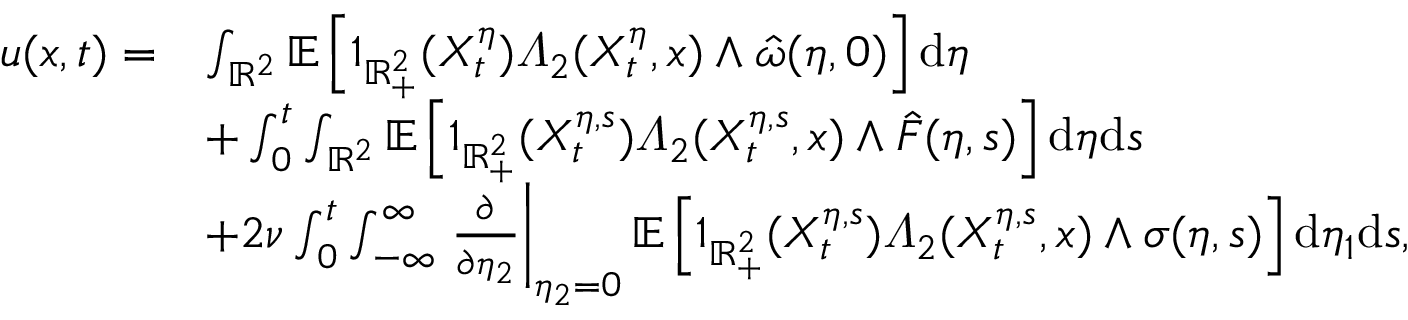Convert formula to latex. <formula><loc_0><loc_0><loc_500><loc_500>\begin{array} { r l } { u ( x , t ) = } & { \int _ { \mathbb { R } ^ { 2 } } \mathbb { E } \left [ 1 _ { \mathbb { R } _ { + } ^ { 2 } } ( X _ { t } ^ { \eta } ) \varLambda _ { 2 } ( X _ { t } ^ { \eta } , x ) \wedge \hat { \omega } ( \eta , 0 ) \right ] d \eta } \\ & { + \int _ { 0 } ^ { t } \int _ { \mathbb { R } ^ { 2 } } \mathbb { E } \left [ 1 _ { \mathbb { R } _ { + } ^ { 2 } } ( X _ { t } ^ { \eta , s } ) \varLambda _ { 2 } ( X _ { t } ^ { \eta , s } , x ) \wedge \hat { F } ( \eta , s ) \right ] d \eta d s } \\ & { + 2 \nu \int _ { 0 } ^ { t } \int _ { - \infty } ^ { \infty } \frac { \partial } { \partial \eta _ { 2 } } \right | _ { \eta _ { 2 } = 0 } \mathbb { E } \left [ 1 _ { \mathbb { R } _ { + } ^ { 2 } } ( X _ { t } ^ { \eta , s } ) \varLambda _ { 2 } ( X _ { t } ^ { \eta , s } , x ) \wedge \sigma ( \eta , s ) \right ] d \eta _ { 1 } d s , } \end{array}</formula> 